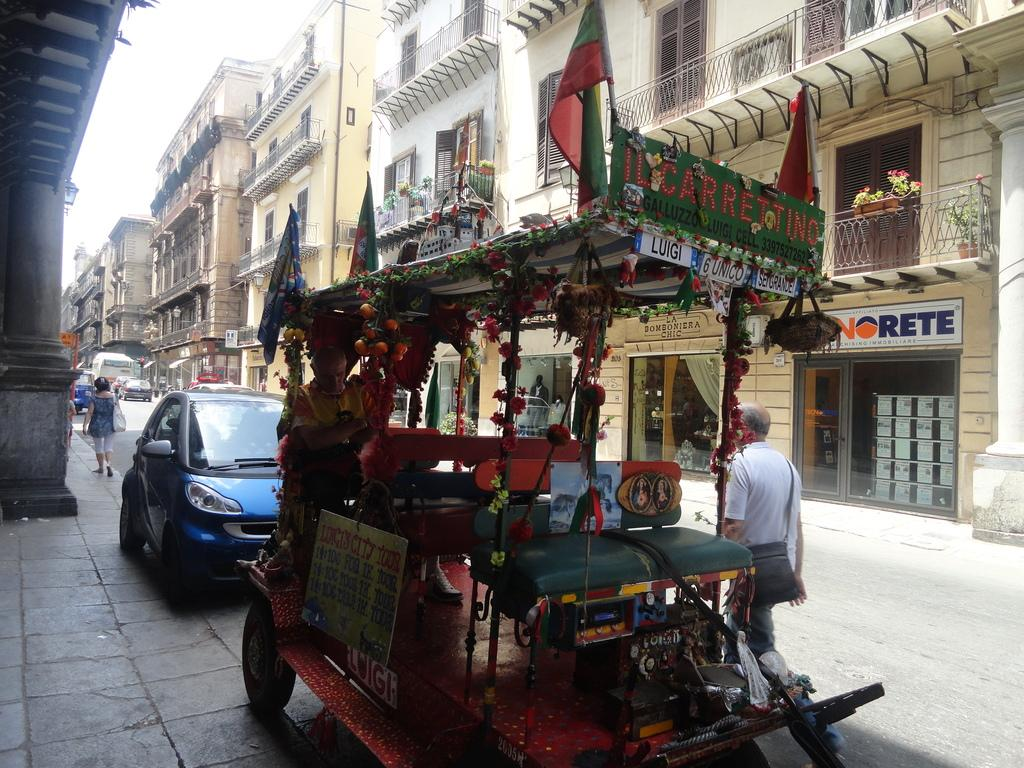What types of objects can be seen in the image? There are vehicles, a group of people, buildings, flower pots, and metal rods visible in the image. Can you describe the vehicles in the image? The vehicles in the image are not specified, but they are present. What is the group of people doing in the image? The activities of the group of people are not specified, but they are present in the image. What type of structures can be seen in the image? Buildings are present in the image. What additional objects can be seen in the image? Flower pots and metal rods are visible in the image. What type of hobbies do the sheep in the image enjoy? There are no sheep present in the image, so their hobbies cannot be determined. How many times does the person in the image sneeze? There is no indication of anyone sneezing in the image, so it cannot be determined. 